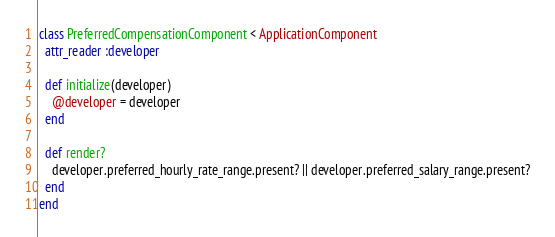Convert code to text. <code><loc_0><loc_0><loc_500><loc_500><_Ruby_>class PreferredCompensationComponent < ApplicationComponent
  attr_reader :developer

  def initialize(developer)
    @developer = developer
  end

  def render?
    developer.preferred_hourly_rate_range.present? || developer.preferred_salary_range.present?
  end
end
</code> 